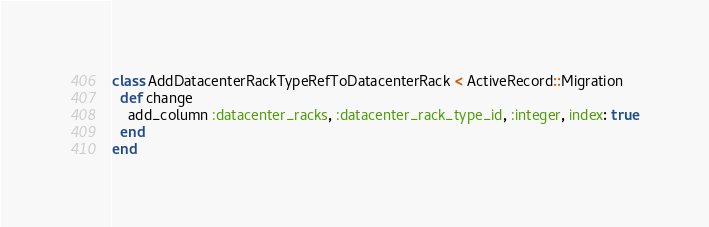<code> <loc_0><loc_0><loc_500><loc_500><_Ruby_>class AddDatacenterRackTypeRefToDatacenterRack < ActiveRecord::Migration
  def change
    add_column :datacenter_racks, :datacenter_rack_type_id, :integer, index: true
  end
end
</code> 